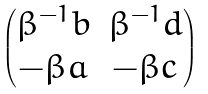Convert formula to latex. <formula><loc_0><loc_0><loc_500><loc_500>\begin{pmatrix} \beta ^ { - 1 } b & \beta ^ { - 1 } d \\ - \beta a & - \beta c \end{pmatrix}</formula> 